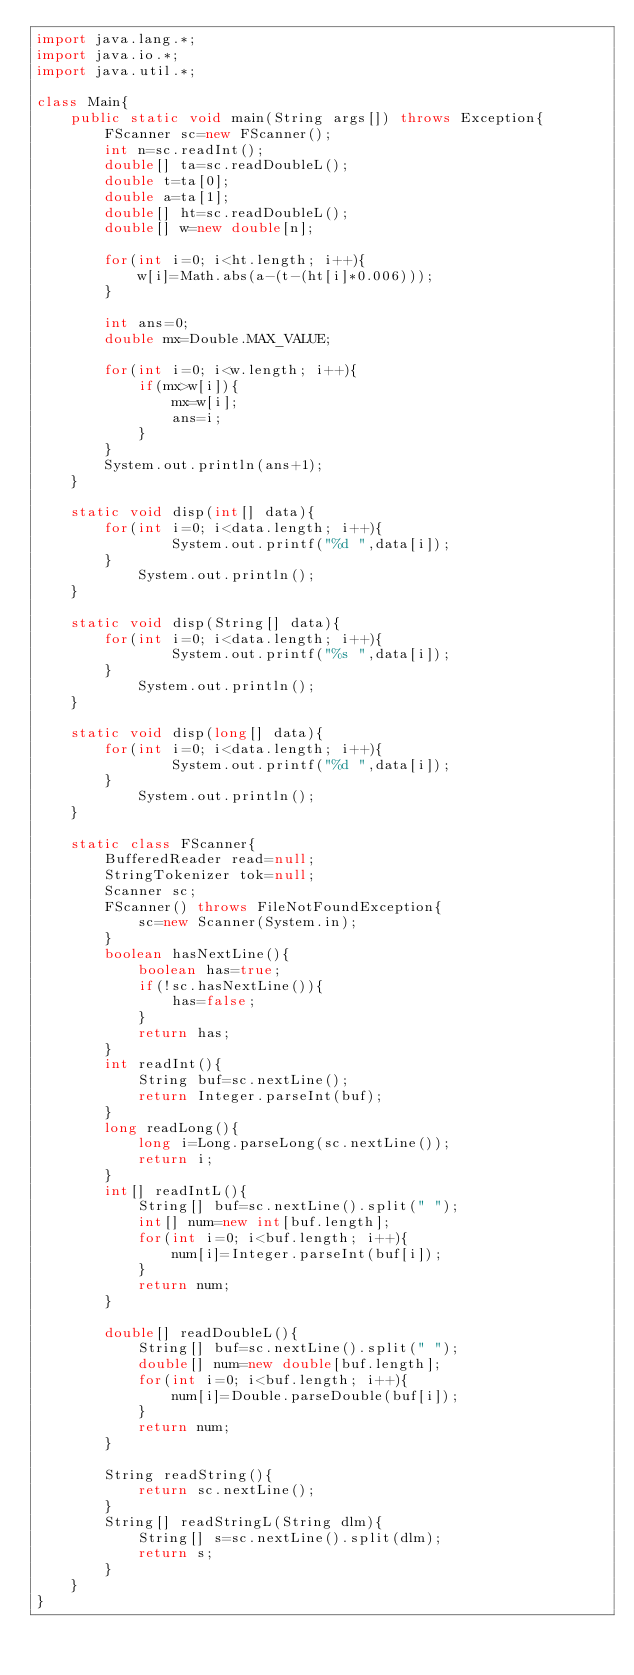Convert code to text. <code><loc_0><loc_0><loc_500><loc_500><_Java_>import java.lang.*;
import java.io.*;
import java.util.*;

class Main{
	public static void main(String args[]) throws Exception{
		FScanner sc=new FScanner();
		int n=sc.readInt();
		double[] ta=sc.readDoubleL();
		double t=ta[0];
		double a=ta[1];
		double[] ht=sc.readDoubleL();
		double[] w=new double[n];
		
		for(int i=0; i<ht.length; i++){
			w[i]=Math.abs(a-(t-(ht[i]*0.006)));
		}
		
		int ans=0;
		double mx=Double.MAX_VALUE;
		
		for(int i=0; i<w.length; i++){
			if(mx>w[i]){
				mx=w[i];
				ans=i;
			}
		}
		System.out.println(ans+1);
	}

	static void disp(int[] data){
		for(int i=0; i<data.length; i++){
				System.out.printf("%d ",data[i]);
		}
			System.out.println();
	}
	
	static void disp(String[] data){
		for(int i=0; i<data.length; i++){
				System.out.printf("%s ",data[i]);
		}
			System.out.println();
	}
	
	static void disp(long[] data){
		for(int i=0; i<data.length; i++){
				System.out.printf("%d ",data[i]);
		}
			System.out.println();
	}
	
	static class FScanner{
		BufferedReader read=null;
		StringTokenizer tok=null;
		Scanner sc;
		FScanner() throws FileNotFoundException{
			sc=new Scanner(System.in);
		}
		boolean hasNextLine(){
			boolean has=true;
			if(!sc.hasNextLine()){
				has=false;
			}
			return has;
		}
		int readInt(){
			String buf=sc.nextLine();
			return Integer.parseInt(buf);
		}
		long readLong(){
			long i=Long.parseLong(sc.nextLine());
			return i;
		}
		int[] readIntL(){
			String[] buf=sc.nextLine().split(" ");
			int[] num=new int[buf.length];
			for(int i=0; i<buf.length; i++){
				num[i]=Integer.parseInt(buf[i]);
			}
			return num;
		}
		
		double[] readDoubleL(){
			String[] buf=sc.nextLine().split(" ");
			double[] num=new double[buf.length];
			for(int i=0; i<buf.length; i++){
				num[i]=Double.parseDouble(buf[i]);
			}
			return num;
		}
		
		String readString(){
			return sc.nextLine();
		}
		String[] readStringL(String dlm){
			String[] s=sc.nextLine().split(dlm);
			return s;
		}
	}
}
</code> 